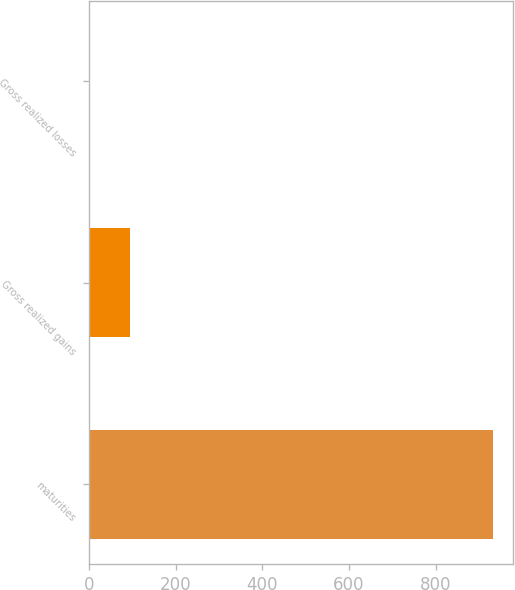Convert chart to OTSL. <chart><loc_0><loc_0><loc_500><loc_500><bar_chart><fcel>maturities<fcel>Gross realized gains<fcel>Gross realized losses<nl><fcel>931<fcel>94.9<fcel>2<nl></chart> 